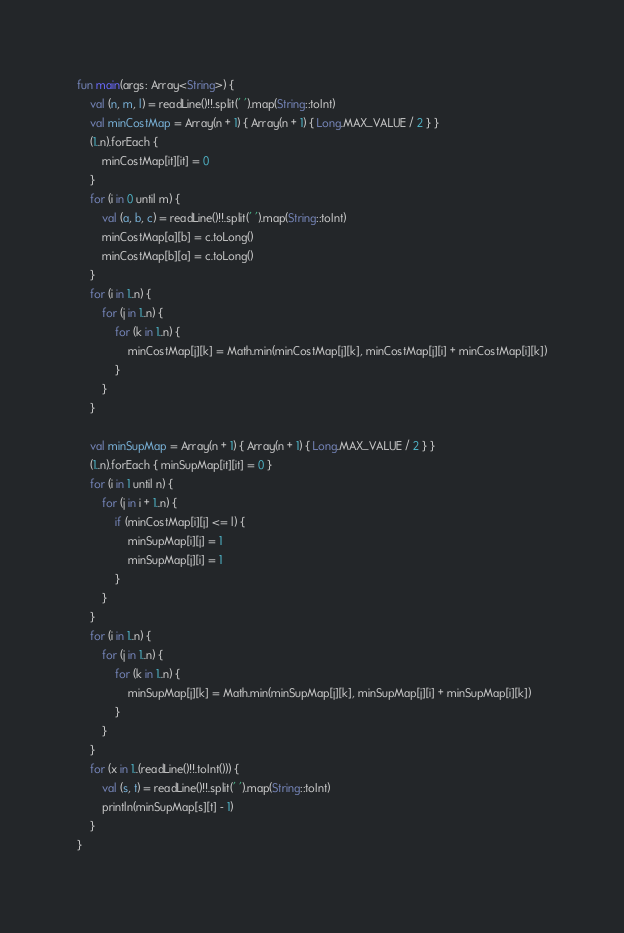Convert code to text. <code><loc_0><loc_0><loc_500><loc_500><_Kotlin_>fun main(args: Array<String>) {
    val (n, m, l) = readLine()!!.split(' ').map(String::toInt)
    val minCostMap = Array(n + 1) { Array(n + 1) { Long.MAX_VALUE / 2 } }
    (1..n).forEach {
        minCostMap[it][it] = 0
    }
    for (i in 0 until m) {
        val (a, b, c) = readLine()!!.split(' ').map(String::toInt)
        minCostMap[a][b] = c.toLong()
        minCostMap[b][a] = c.toLong()
    }
    for (i in 1..n) {
        for (j in 1..n) {
            for (k in 1..n) {
                minCostMap[j][k] = Math.min(minCostMap[j][k], minCostMap[j][i] + minCostMap[i][k])
            }
        }
    }

    val minSupMap = Array(n + 1) { Array(n + 1) { Long.MAX_VALUE / 2 } }
    (1..n).forEach { minSupMap[it][it] = 0 }
    for (i in 1 until n) {
        for (j in i + 1..n) {
            if (minCostMap[i][j] <= l) {
                minSupMap[i][j] = 1
                minSupMap[j][i] = 1
            }
        }
    }
    for (i in 1..n) {
        for (j in 1..n) {
            for (k in 1..n) {
                minSupMap[j][k] = Math.min(minSupMap[j][k], minSupMap[j][i] + minSupMap[i][k])
            }
        }
    }
    for (x in 1..(readLine()!!.toInt())) {
        val (s, t) = readLine()!!.split(' ').map(String::toInt)
        println(minSupMap[s][t] - 1)
    }
}</code> 